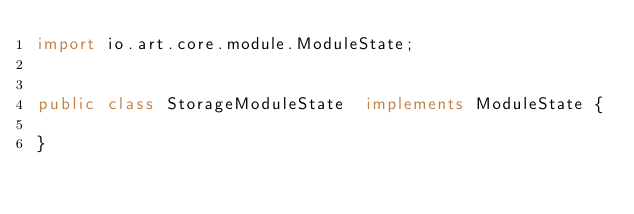Convert code to text. <code><loc_0><loc_0><loc_500><loc_500><_Java_>import io.art.core.module.ModuleState;


public class StorageModuleState  implements ModuleState {

}
</code> 